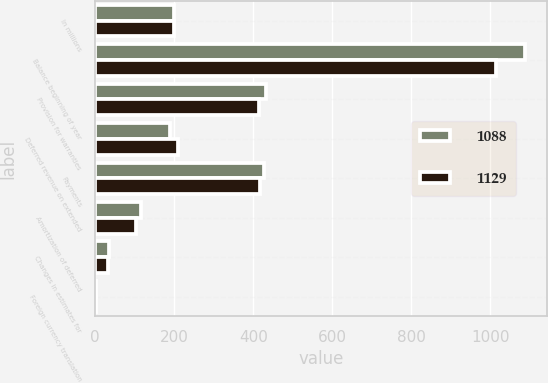Convert chart to OTSL. <chart><loc_0><loc_0><loc_500><loc_500><stacked_bar_chart><ecel><fcel>In millions<fcel>Balance beginning of year<fcel>Provision for warranties<fcel>Deferred revenue on extended<fcel>Payments<fcel>Amortization of deferred<fcel>Changes in estimates for<fcel>Foreign currency translation<nl><fcel>1088<fcel>199.5<fcel>1088<fcel>431<fcel>189<fcel>427<fcel>115<fcel>35<fcel>2<nl><fcel>1129<fcel>199.5<fcel>1014<fcel>415<fcel>210<fcel>416<fcel>103<fcel>33<fcel>1<nl></chart> 